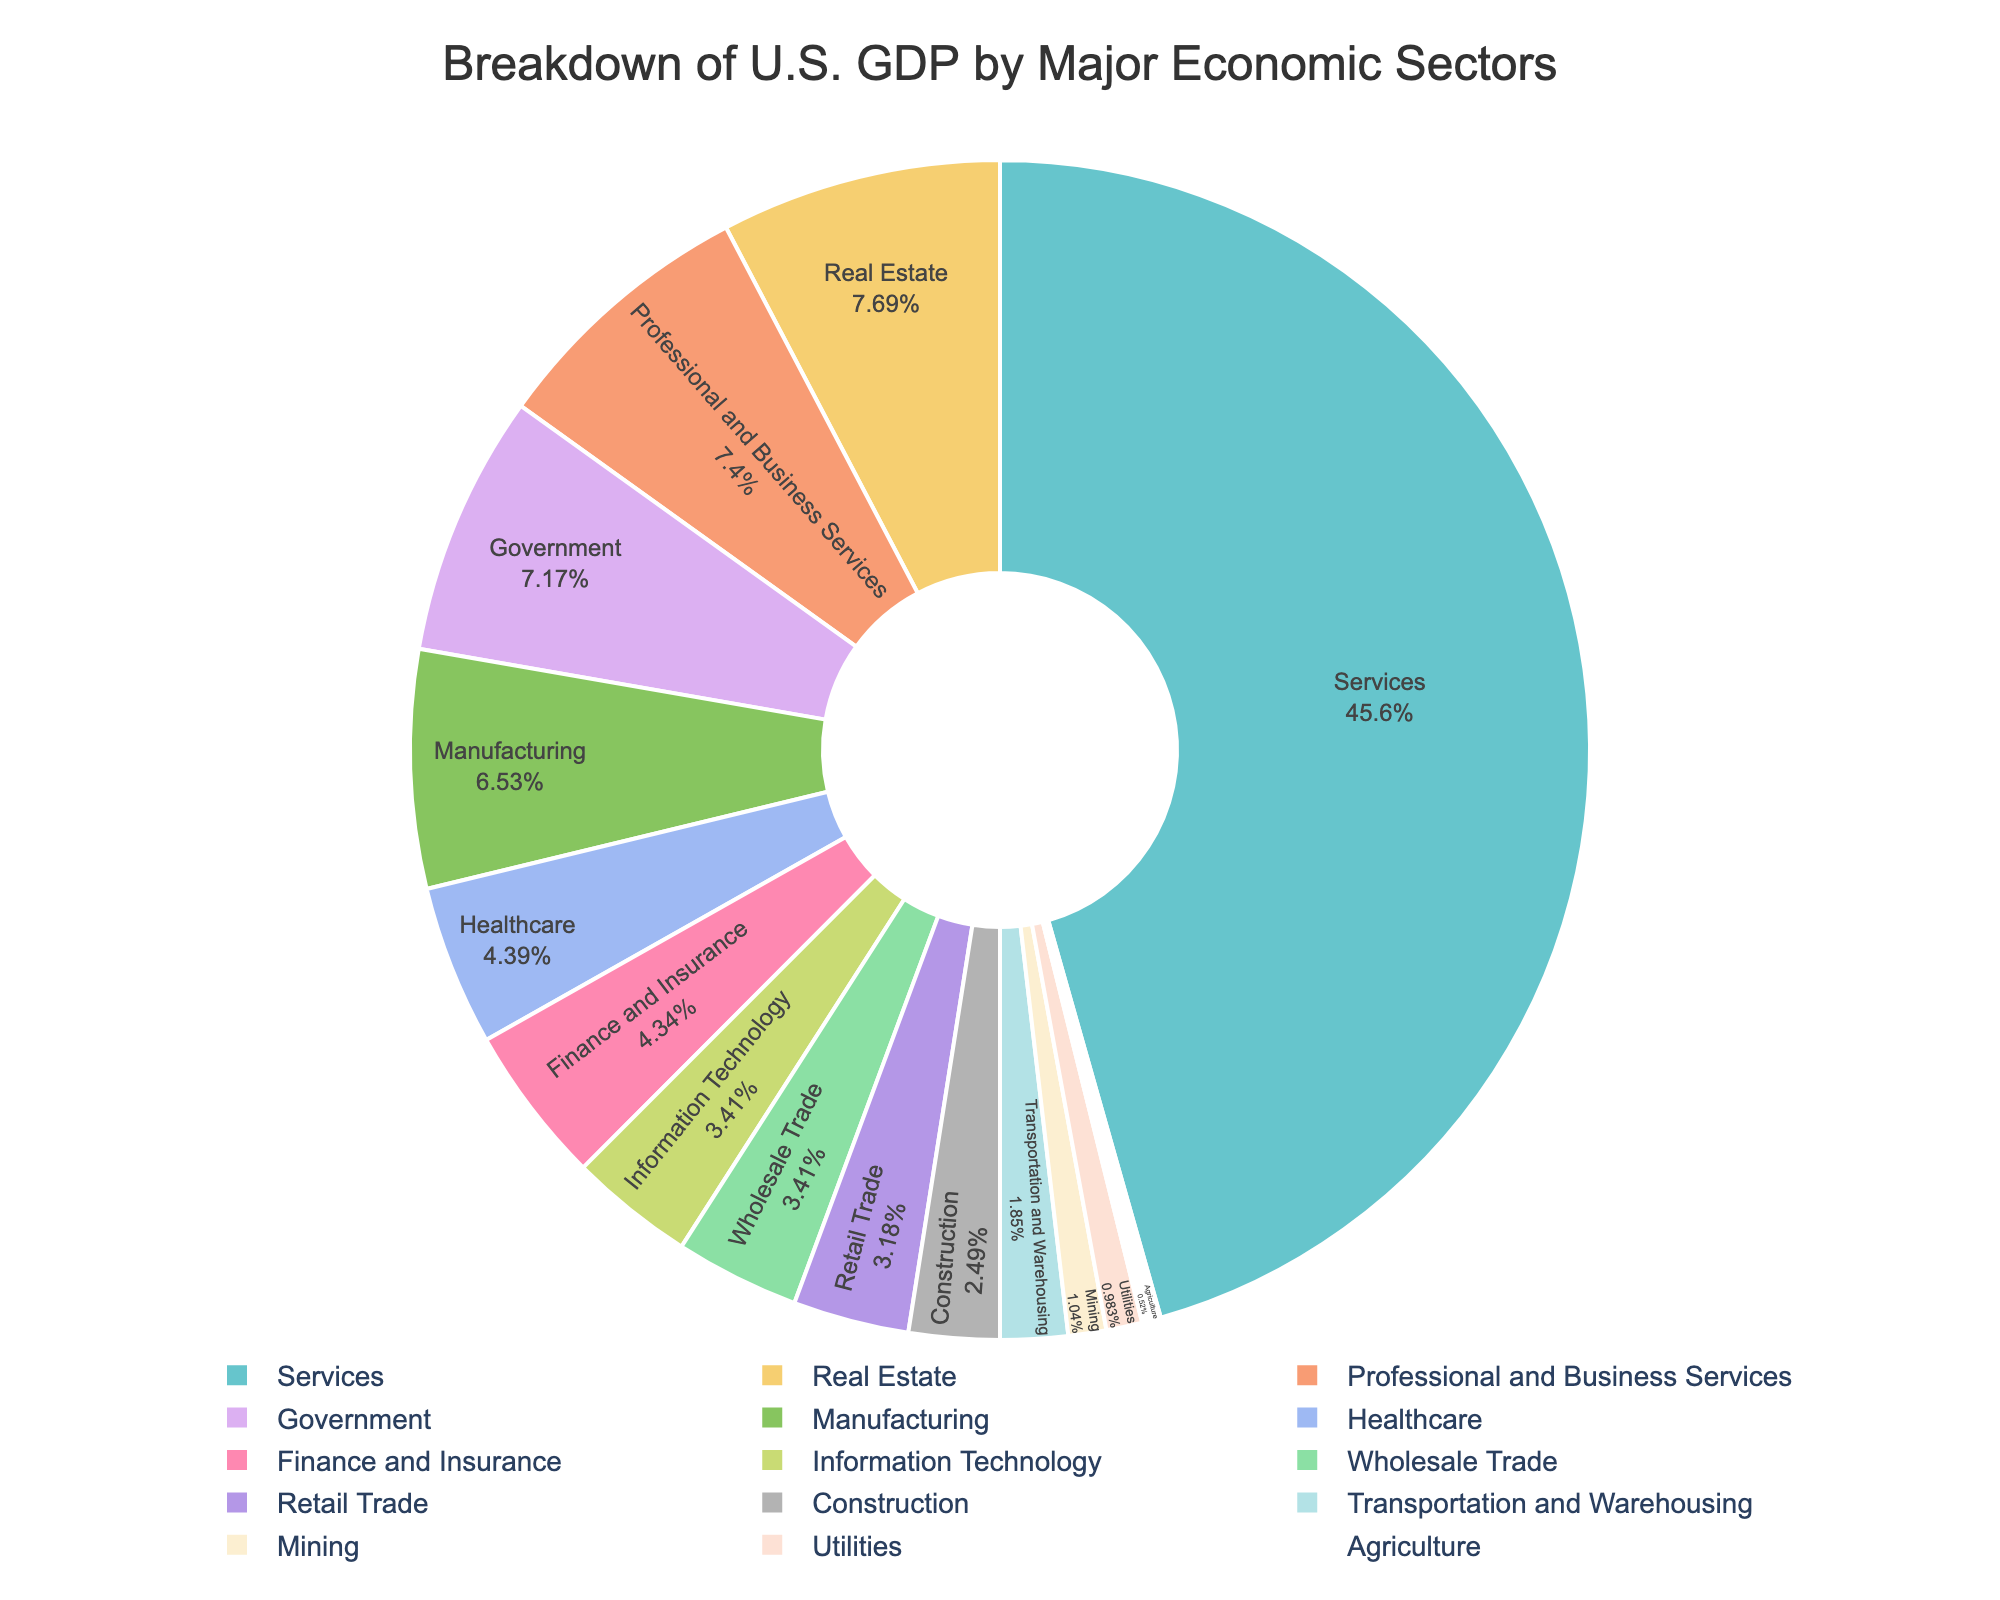What percentage of the U.S. GDP is contributed by the Services sector? The Services sector accounts for 78.9% of the U.S. GDP, as shown by the figure.
Answer: 78.9% Which sector contributes more to the U.S. GDP, Manufacturing or Finance and Insurance? The figure shows that Manufacturing contributes 11.3% and Finance and Insurance contributes 7.5%. Hence, Manufacturing contributes more.
Answer: Manufacturing Is the combined contribution of Agriculture, Mining, and Utilities greater than the contribution of Professional and Business Services? The combined contribution of Agriculture (0.9%), Mining (1.8%), and Utilities (1.7%) is 0.9 + 1.8 + 1.7 = 4.4%. Professional and Business Services contribute 12.8%. Therefore, the combined contribution of these three sectors is less than that of Professional and Business Services.
Answer: No What is the difference in percentage contribution between Real Estate and Retail Trade? From the figure, Real Estate contributes 13.3% and Retail Trade contributes 5.5%. So, the difference is 13.3 - 5.5 = 7.8%.
Answer: 7.8% Are the combined percentages of Healthcare and Information Technology more than the percentage of Government? Healthcare contributes 7.6% and Information Technology contributes 5.9%, so together they contribute 7.6 + 5.9 = 13.5%. Government contributes 12.4%, so the combined healthcare and IT percentage is higher.
Answer: Yes What is the largest contributing sector to the U.S. GDP? The figure indicates that the Services sector is the largest contributor to the U.S. GDP at 78.9%.
Answer: Services Which sector contributes around 5% to the U.S. GDP? The figure indicates that Information Technology and Wholesale Trade both contribute around 5.9% and Retail Trade contributes 5.5%, so Retail Trade is around 5%.
Answer: Retail Trade How many sectors contribute less than 2% to the U.S. GDP? By checking the figure, the sectors contributing less than 2% are Agriculture (0.9%), Mining (1.8%), and Utilities (1.7%). Hence, there are 3 sectors.
Answer: 3 